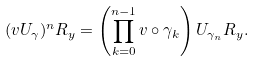<formula> <loc_0><loc_0><loc_500><loc_500>( v U _ { \gamma } ) ^ { n } R _ { y } = \left ( \prod _ { k = 0 } ^ { n - 1 } v \circ \gamma _ { k } \right ) U _ { \gamma _ { n } } R _ { y } .</formula> 